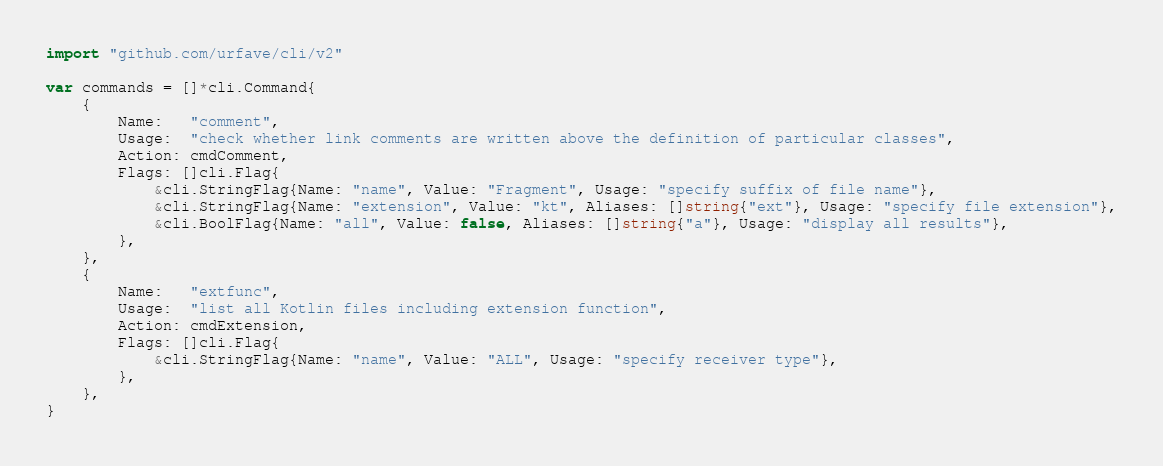Convert code to text. <code><loc_0><loc_0><loc_500><loc_500><_Go_>import "github.com/urfave/cli/v2"

var commands = []*cli.Command{
	{
		Name:   "comment",
		Usage:  "check whether link comments are written above the definition of particular classes",
		Action: cmdComment,
		Flags: []cli.Flag{
			&cli.StringFlag{Name: "name", Value: "Fragment", Usage: "specify suffix of file name"},
			&cli.StringFlag{Name: "extension", Value: "kt", Aliases: []string{"ext"}, Usage: "specify file extension"},
			&cli.BoolFlag{Name: "all", Value: false, Aliases: []string{"a"}, Usage: "display all results"},
		},
	},
	{
		Name:   "extfunc",
		Usage:  "list all Kotlin files including extension function",
		Action: cmdExtension,
		Flags: []cli.Flag{
			&cli.StringFlag{Name: "name", Value: "ALL", Usage: "specify receiver type"},
		},
	},
}
</code> 